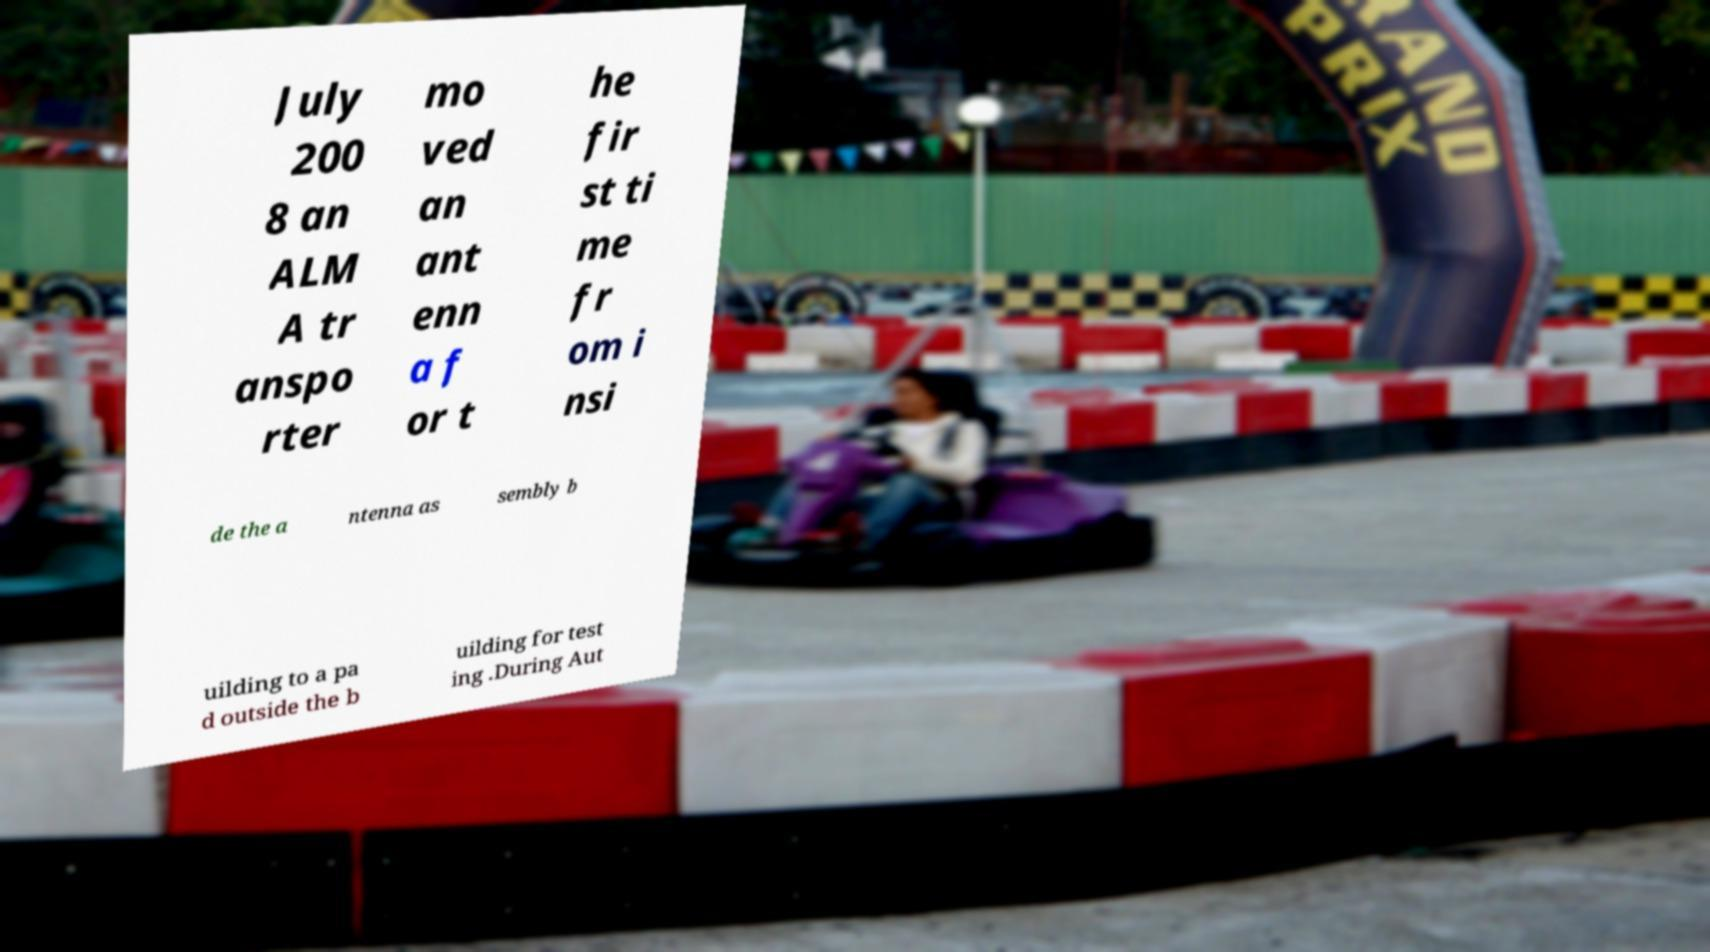There's text embedded in this image that I need extracted. Can you transcribe it verbatim? July 200 8 an ALM A tr anspo rter mo ved an ant enn a f or t he fir st ti me fr om i nsi de the a ntenna as sembly b uilding to a pa d outside the b uilding for test ing .During Aut 